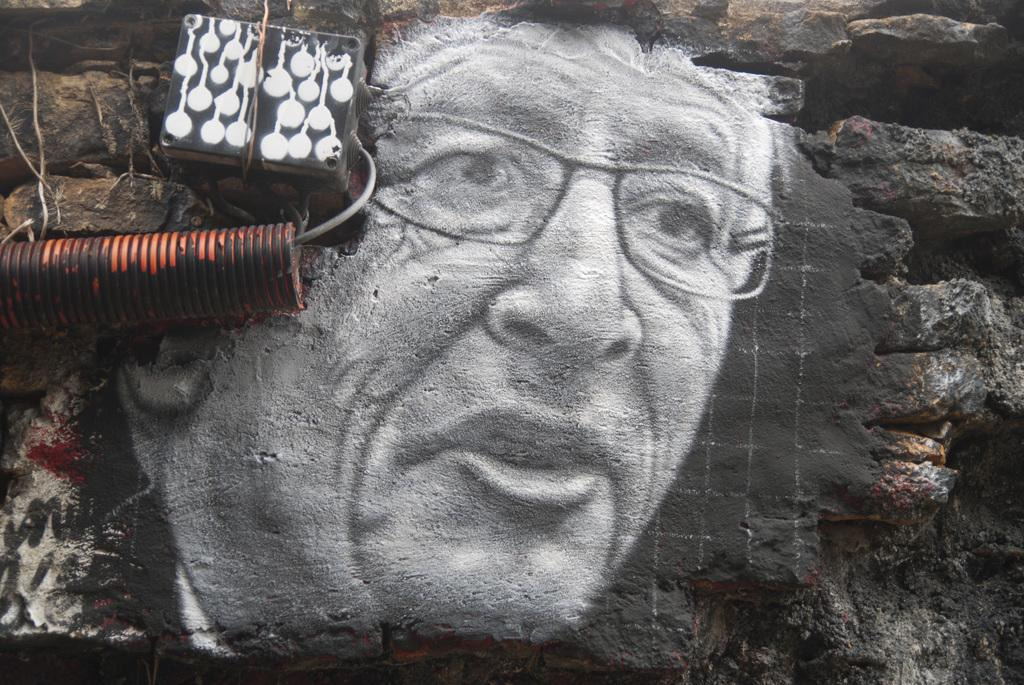What is displayed on the wall in the image? There is an art piece on the wall in the image. What can be seen on the left side of the image? There is a pipe and a cable on the left side of the image. What type of debt is being discussed in the image? There is no mention of debt in the image; it features an art piece on the wall and a pipe and cable on the left side. 